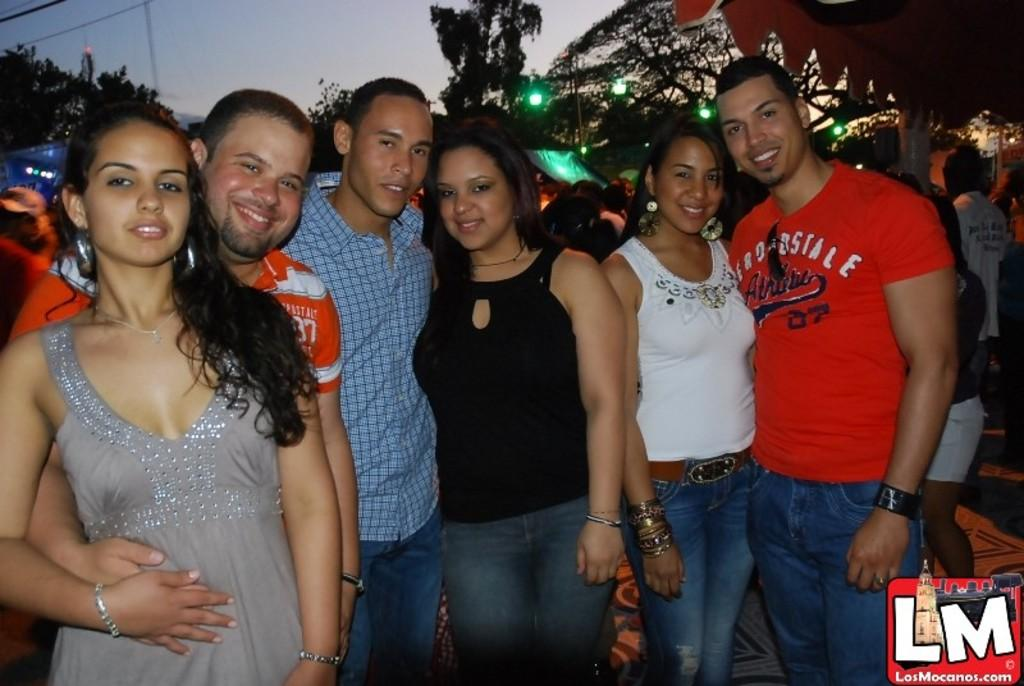What is happening in the image? There is a group of people standing in the image. What can be seen in the background of the image? There are trees, lights, and the sky visible in the background of the image. How many snails are crawling on the people in the image? There are no snails present in the image; it features a group of people standing with no snails visible. 